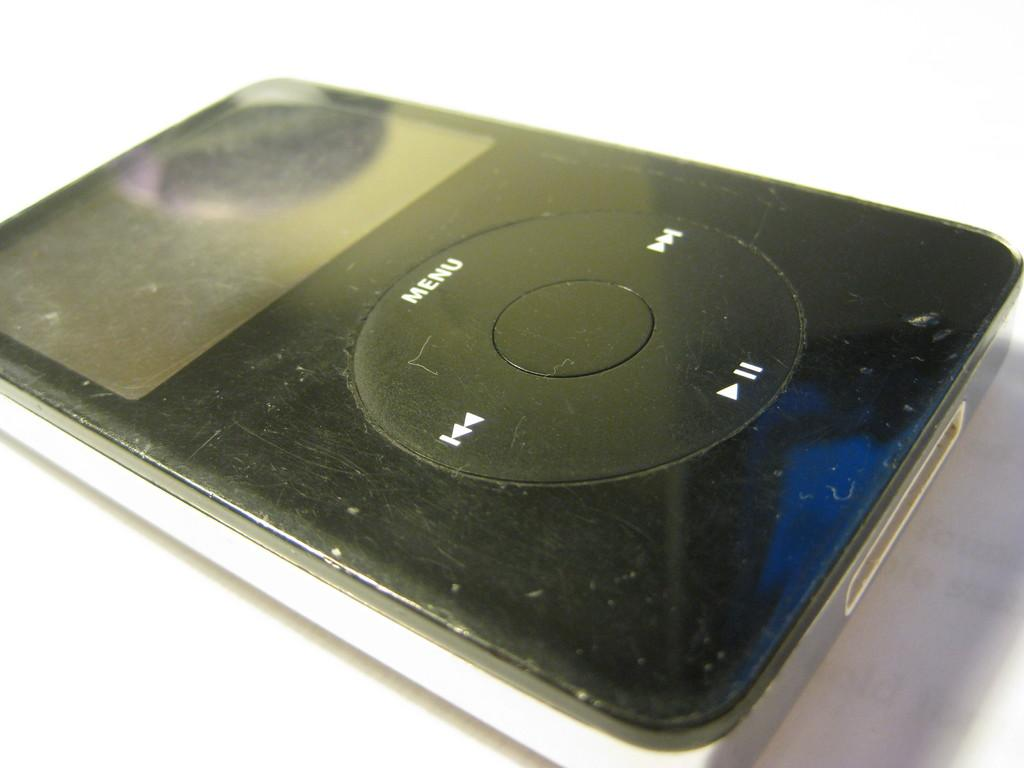What type of object is located in the center of the image? There is an electronic device in the center of the image. What type of disease is affecting the electronic device in the image? There is no indication of a disease affecting the electronic device in the image, as it is an inanimate object. 